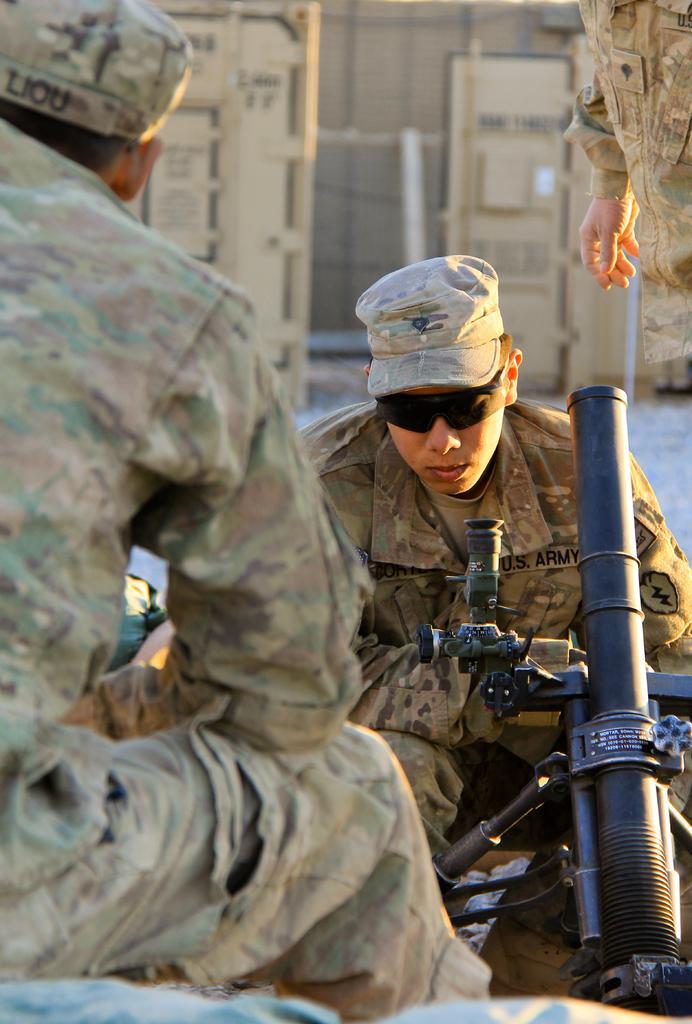Can you describe this image briefly? This image is taken outdoors. In the background there is a wall. On the right side of the image there is a person standing on the ground and a man is sitting and there is a gun. On the left side of the image a man is sitting. 